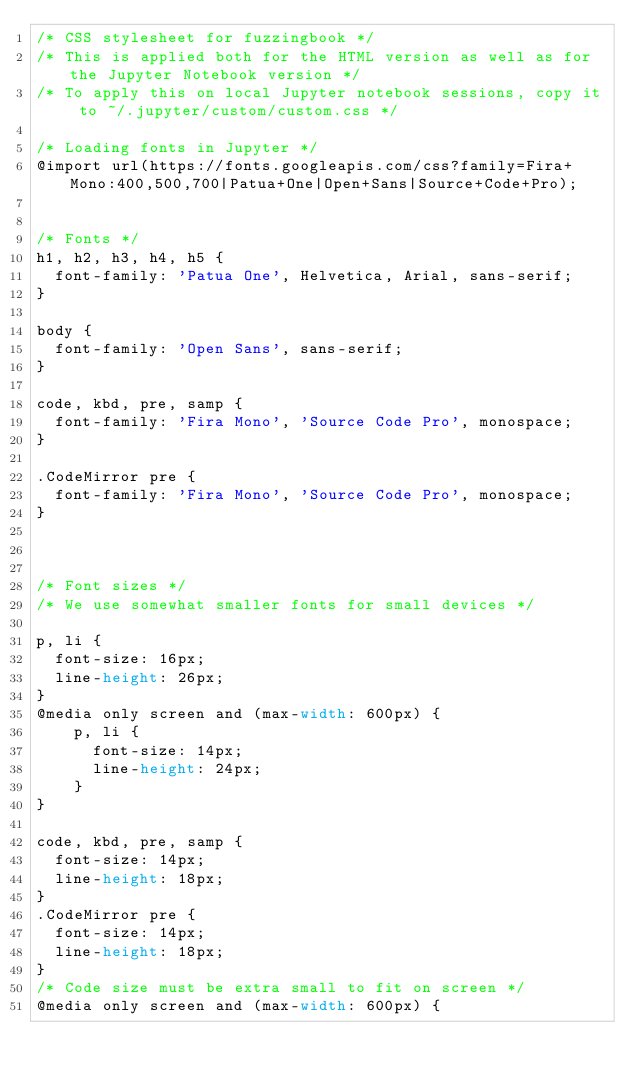<code> <loc_0><loc_0><loc_500><loc_500><_CSS_>/* CSS stylesheet for fuzzingbook */
/* This is applied both for the HTML version as well as for the Jupyter Notebook version */
/* To apply this on local Jupyter notebook sessions, copy it to ~/.jupyter/custom/custom.css */

/* Loading fonts in Jupyter */
@import url(https://fonts.googleapis.com/css?family=Fira+Mono:400,500,700|Patua+One|Open+Sans|Source+Code+Pro);


/* Fonts */
h1, h2, h3, h4, h5 {
	font-family: 'Patua One', Helvetica, Arial, sans-serif;
}

body {
  font-family: 'Open Sans', sans-serif;
}

code, kbd, pre, samp {
  font-family: 'Fira Mono', 'Source Code Pro', monospace;
}

.CodeMirror pre {
  font-family: 'Fira Mono', 'Source Code Pro', monospace;
}



/* Font sizes */
/* We use somewhat smaller fonts for small devices */

p, li {
	font-size: 16px;
	line-height: 26px;
}
@media only screen and (max-width: 600px) {
    p, li {
    	font-size: 14px;
    	line-height: 24px;
    }
}

code, kbd, pre, samp {
  font-size: 14px;
  line-height: 18px;
}
.CodeMirror pre {
  font-size: 14px;
  line-height: 18px;
}
/* Code size must be extra small to fit on screen */
@media only screen and (max-width: 600px) {</code> 